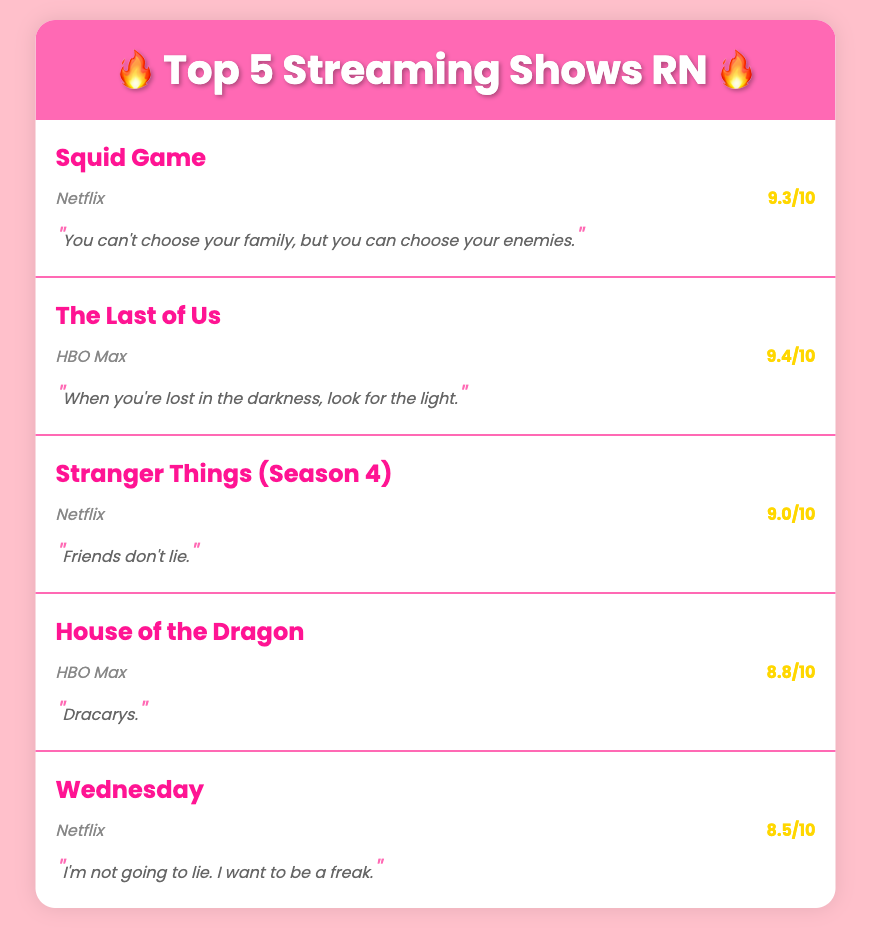What is the highest rating among the shows? The highest rating is compared across all the shows listed, and the highest rating is 9.4/10 for The Last of Us.
Answer: 9.4/10 Which platform is Squid Game available on? The document lists the platform under each show, and Squid Game is available on Netflix.
Answer: Netflix What iconic quote is associated with House of the Dragon? The quote for House of the Dragon is provided in the document, which states "Dracarys."
Answer: Dracarys How many shows are listed in the document? The document presents a numbered list of shows, counting a total of five shows.
Answer: 5 What is the rating for Wednesday? The rating for Wednesday is specifically stated in the document, which is 8.5/10.
Answer: 8.5/10 Which show has the quote "Friends don't lie"? The quote is specifically aligned with its respective show in the list, and it belongs to Stranger Things (Season 4).
Answer: Stranger Things (Season 4) 